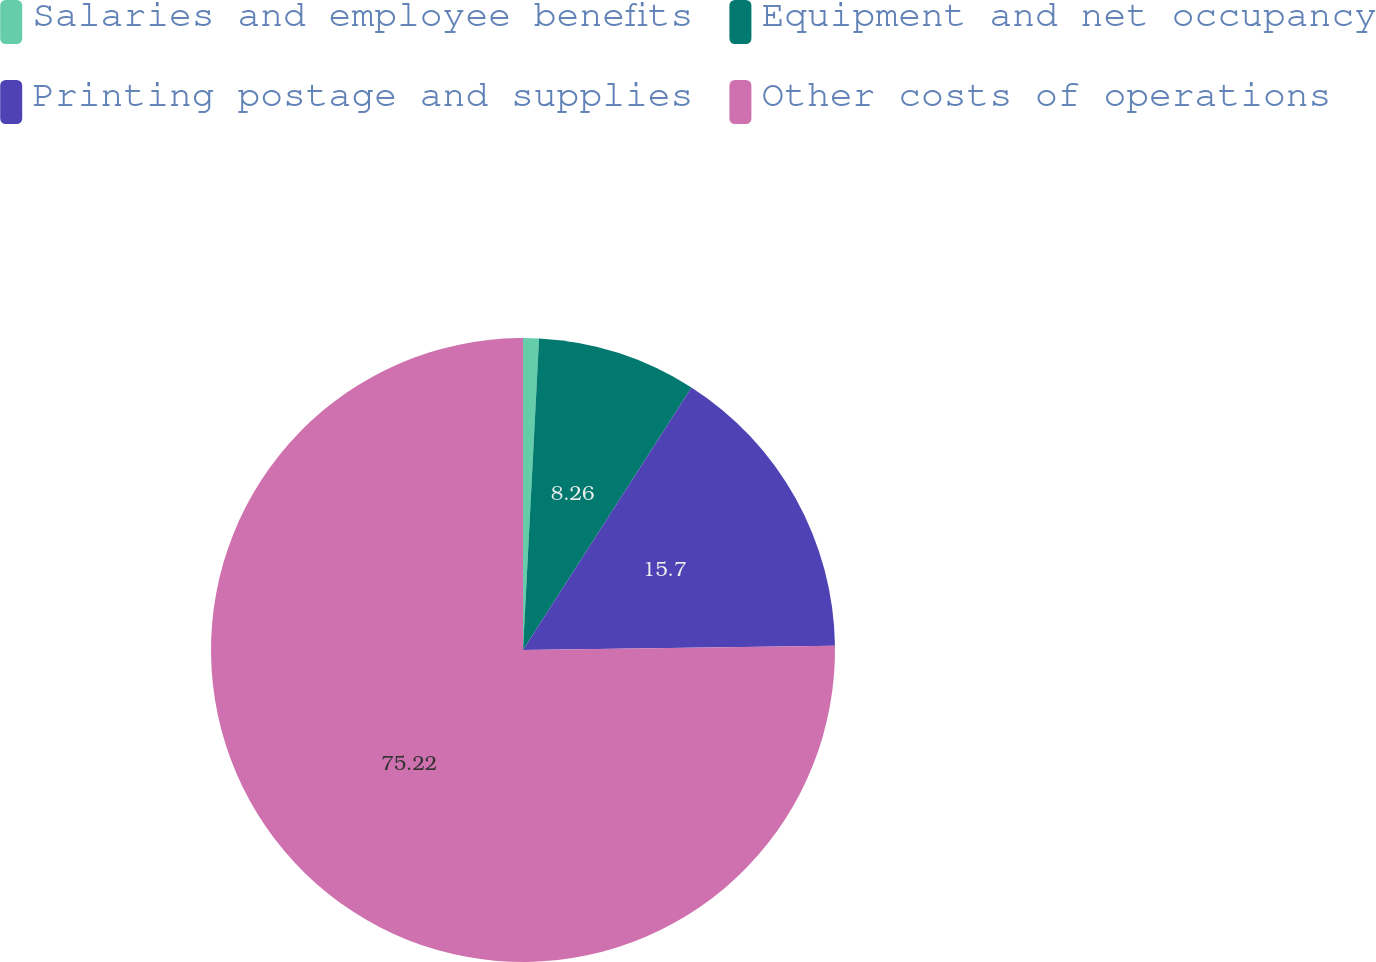Convert chart. <chart><loc_0><loc_0><loc_500><loc_500><pie_chart><fcel>Salaries and employee benefits<fcel>Equipment and net occupancy<fcel>Printing postage and supplies<fcel>Other costs of operations<nl><fcel>0.82%<fcel>8.26%<fcel>15.7%<fcel>75.23%<nl></chart> 